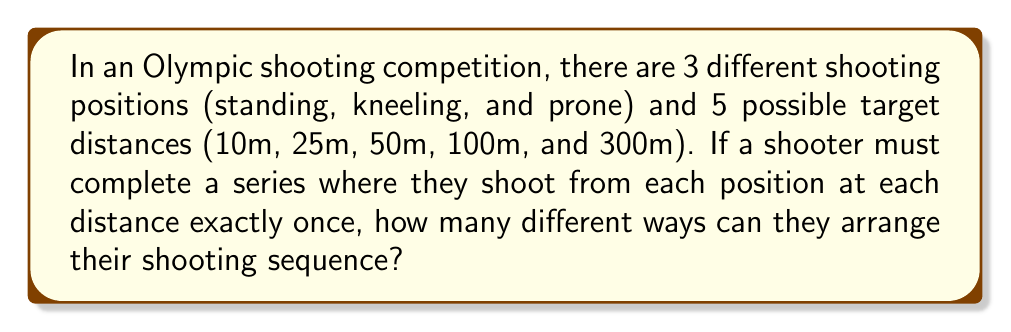Show me your answer to this math problem. To solve this problem, we need to use the concept of permutations from combinatorial mathematics. Let's break it down step by step:

1) First, we need to determine the total number of unique combinations of position and distance. Since there are 3 positions and 5 distances, and each position can be paired with each distance, we have:

   $3 \times 5 = 15$ unique combinations

2) Now, we need to arrange these 15 combinations in a sequence. This is a permutation problem, as the order matters (the sequence of shots).

3) The number of permutations of n distinct objects is given by n!. In this case, we have 15 distinct position-distance combinations, so we need to calculate 15!.

4) Using the factorial notation:

   $$15! = 15 \times 14 \times 13 \times 12 \times ... \times 3 \times 2 \times 1$$

5) Calculating this out:

   $$15! = 1,307,674,368,000$$

Therefore, there are 1,307,674,368,000 different ways to arrange the shooting sequence.
Answer: $1,307,674,368,000$ 